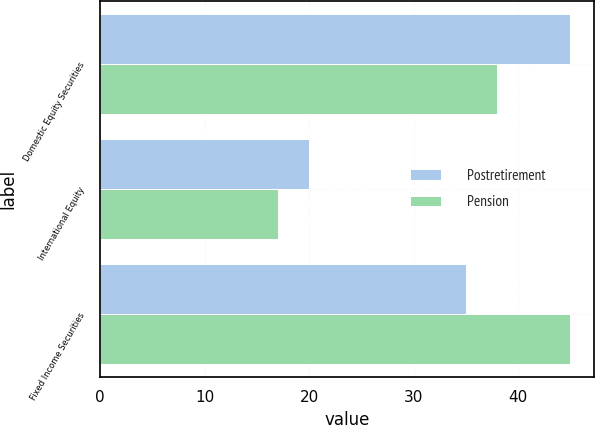Convert chart to OTSL. <chart><loc_0><loc_0><loc_500><loc_500><stacked_bar_chart><ecel><fcel>Domestic Equity Securities<fcel>International Equity<fcel>Fixed Income Securities<nl><fcel>Postretirement<fcel>45<fcel>20<fcel>35<nl><fcel>Pension<fcel>38<fcel>17<fcel>45<nl></chart> 